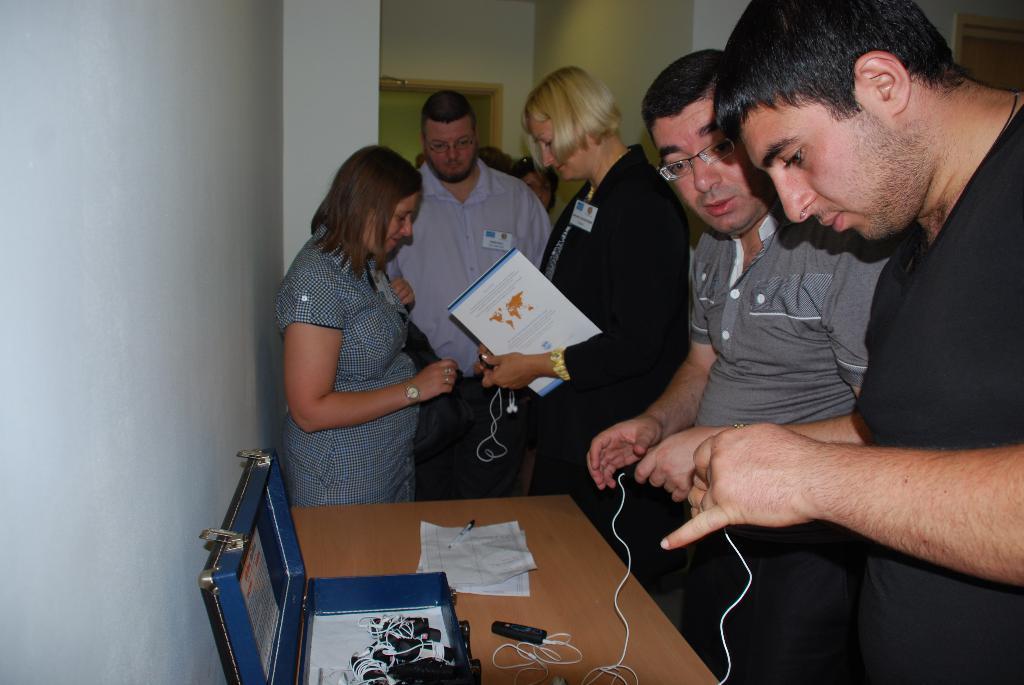Describe this image in one or two sentences. In this image we can see a few people, one of them is holding a file, there is a table, on that there is a briefcase, papers, pen, and some other objects, there are some objects in the briefcase, also we can see the walls. 